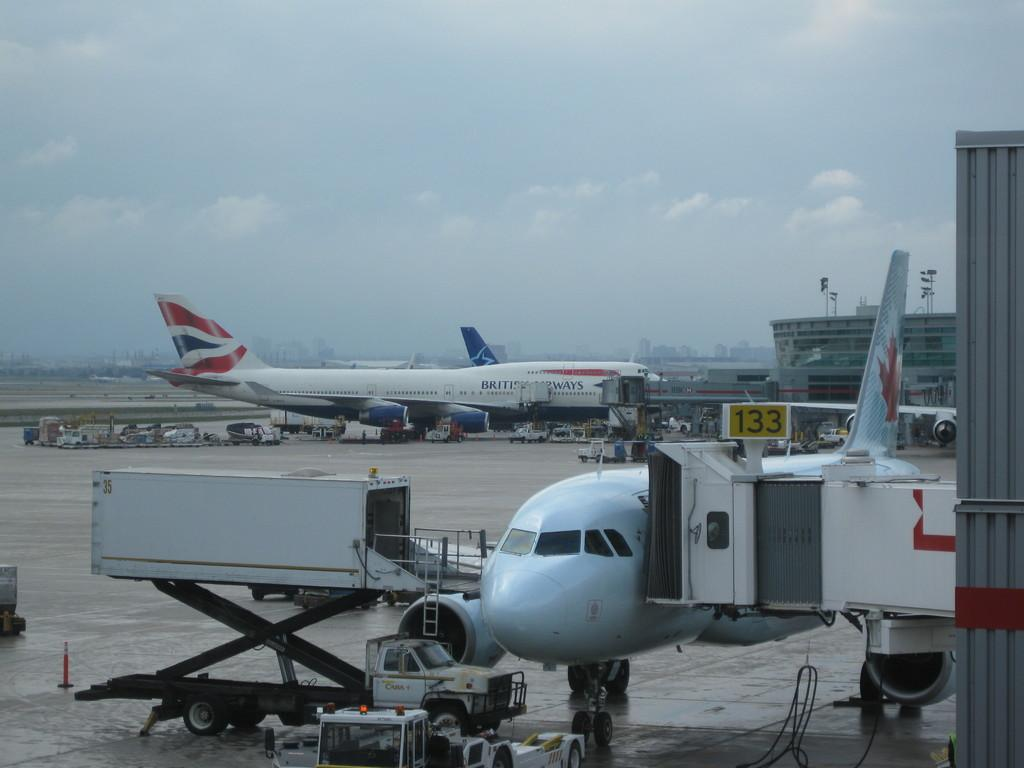<image>
Render a clear and concise summary of the photo. A British Airways jet is being loaded at terminal 133. 